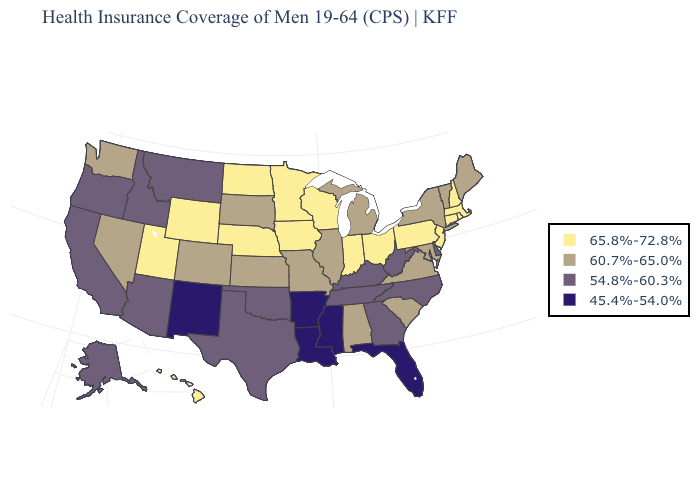Name the states that have a value in the range 45.4%-54.0%?
Quick response, please. Arkansas, Florida, Louisiana, Mississippi, New Mexico. Name the states that have a value in the range 60.7%-65.0%?
Write a very short answer. Alabama, Colorado, Illinois, Kansas, Maine, Maryland, Michigan, Missouri, Nevada, New York, South Carolina, South Dakota, Vermont, Virginia, Washington. Name the states that have a value in the range 65.8%-72.8%?
Answer briefly. Connecticut, Hawaii, Indiana, Iowa, Massachusetts, Minnesota, Nebraska, New Hampshire, New Jersey, North Dakota, Ohio, Pennsylvania, Rhode Island, Utah, Wisconsin, Wyoming. What is the lowest value in the West?
Answer briefly. 45.4%-54.0%. Does the first symbol in the legend represent the smallest category?
Answer briefly. No. Does Vermont have the highest value in the USA?
Quick response, please. No. Name the states that have a value in the range 65.8%-72.8%?
Write a very short answer. Connecticut, Hawaii, Indiana, Iowa, Massachusetts, Minnesota, Nebraska, New Hampshire, New Jersey, North Dakota, Ohio, Pennsylvania, Rhode Island, Utah, Wisconsin, Wyoming. Among the states that border North Carolina , which have the highest value?
Keep it brief. South Carolina, Virginia. How many symbols are there in the legend?
Concise answer only. 4. What is the lowest value in the West?
Concise answer only. 45.4%-54.0%. What is the lowest value in the South?
Give a very brief answer. 45.4%-54.0%. Name the states that have a value in the range 54.8%-60.3%?
Give a very brief answer. Alaska, Arizona, California, Delaware, Georgia, Idaho, Kentucky, Montana, North Carolina, Oklahoma, Oregon, Tennessee, Texas, West Virginia. What is the value of South Carolina?
Short answer required. 60.7%-65.0%. What is the value of Washington?
Quick response, please. 60.7%-65.0%. 